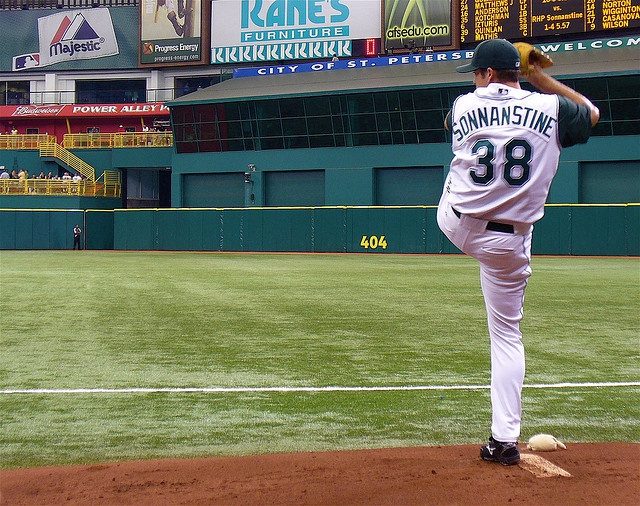Describe the objects in this image and their specific colors. I can see people in black, lavender, darkgray, and gray tones, baseball glove in black, maroon, and orange tones, people in black, navy, blue, and maroon tones, people in black, darkgray, lavender, and gray tones, and people in black, navy, brown, and gray tones in this image. 